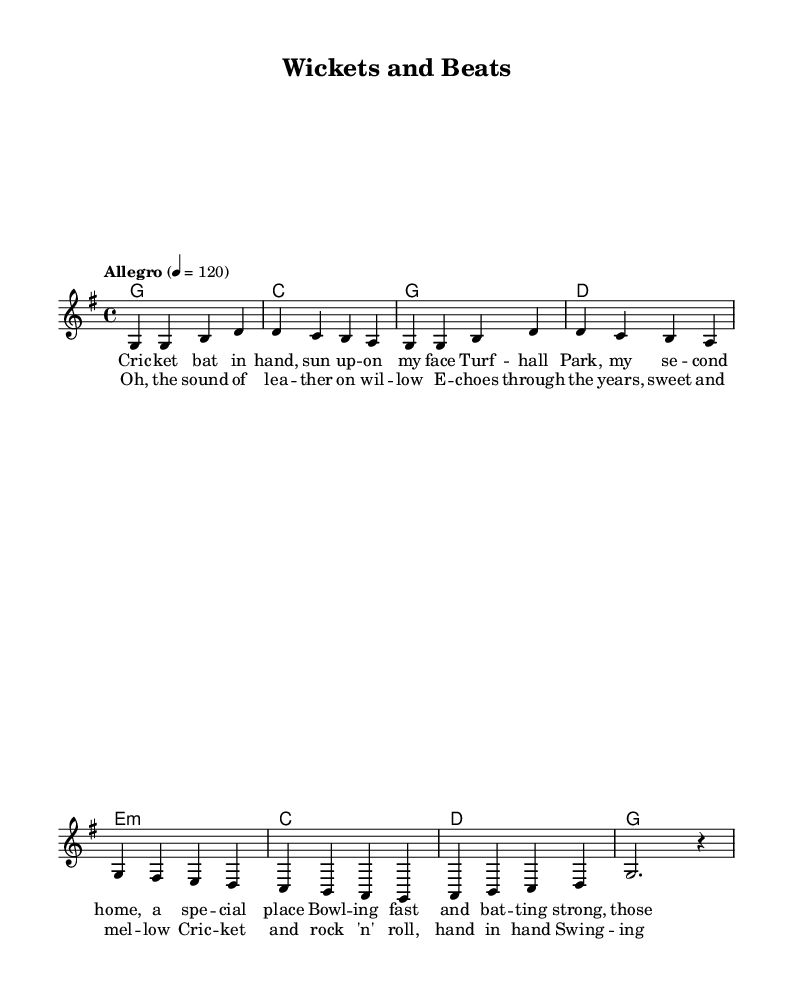What is the key signature of this music? The key signature is indicated at the beginning of the staff. Here, it shows one sharp, which corresponds to G major.
Answer: G major What is the time signature of this music? The time signature is found at the beginning of the staff, which shows that there are 4 beats in each measure and the quarter note gets one beat. This is indicated by the numerator of 4 and the denominator of 4.
Answer: 4/4 What is the tempo marking for this piece? The tempo marking indicates the speed of the piece. Here, it is marked as "Allegro" with a beat of 120 per minute, meaning it should be played fast.
Answer: Allegro 4 = 120 How many measures are in the chorus section? By counting the measures that contain the lyrics of the chorus, we see that there are four measures. Each line of lyrics typically corresponds to one measure.
Answer: 4 What is the primary theme expressed in the lyrics? The lyrics discuss themes of cricket and nostalgia for youth, focusing on memories associated with playing cricket in Turfhall Park during summer.
Answer: Cricket and nostalgia Which section contains the lyrics "Oh, the sound of leather on willow"? By looking at the structure of the lyrics in the score, this line appears in the chorus section, which reflects the main thematic material of the song.
Answer: Chorus 